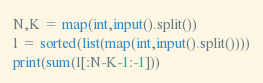Convert code to text. <code><loc_0><loc_0><loc_500><loc_500><_Python_>N,K = map(int,input().split())
l = sorted(list(map(int,input().split())))
print(sum(l[:N-K-1:-1]))</code> 